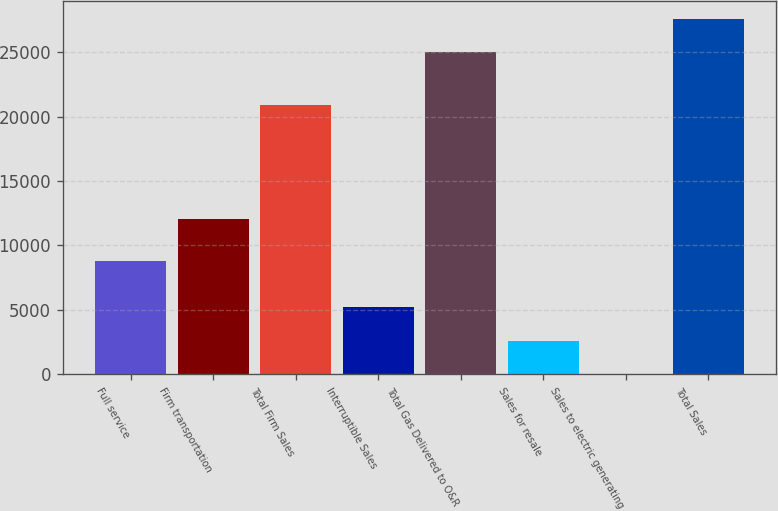Convert chart. <chart><loc_0><loc_0><loc_500><loc_500><bar_chart><fcel>Full service<fcel>Firm transportation<fcel>Total Firm Sales<fcel>Interruptible Sales<fcel>Total Gas Delivered to O&R<fcel>Sales for resale<fcel>Sales to electric generating<fcel>Total Sales<nl><fcel>8808<fcel>12062<fcel>20870<fcel>5193.6<fcel>24988<fcel>2606.3<fcel>19<fcel>27575.3<nl></chart> 